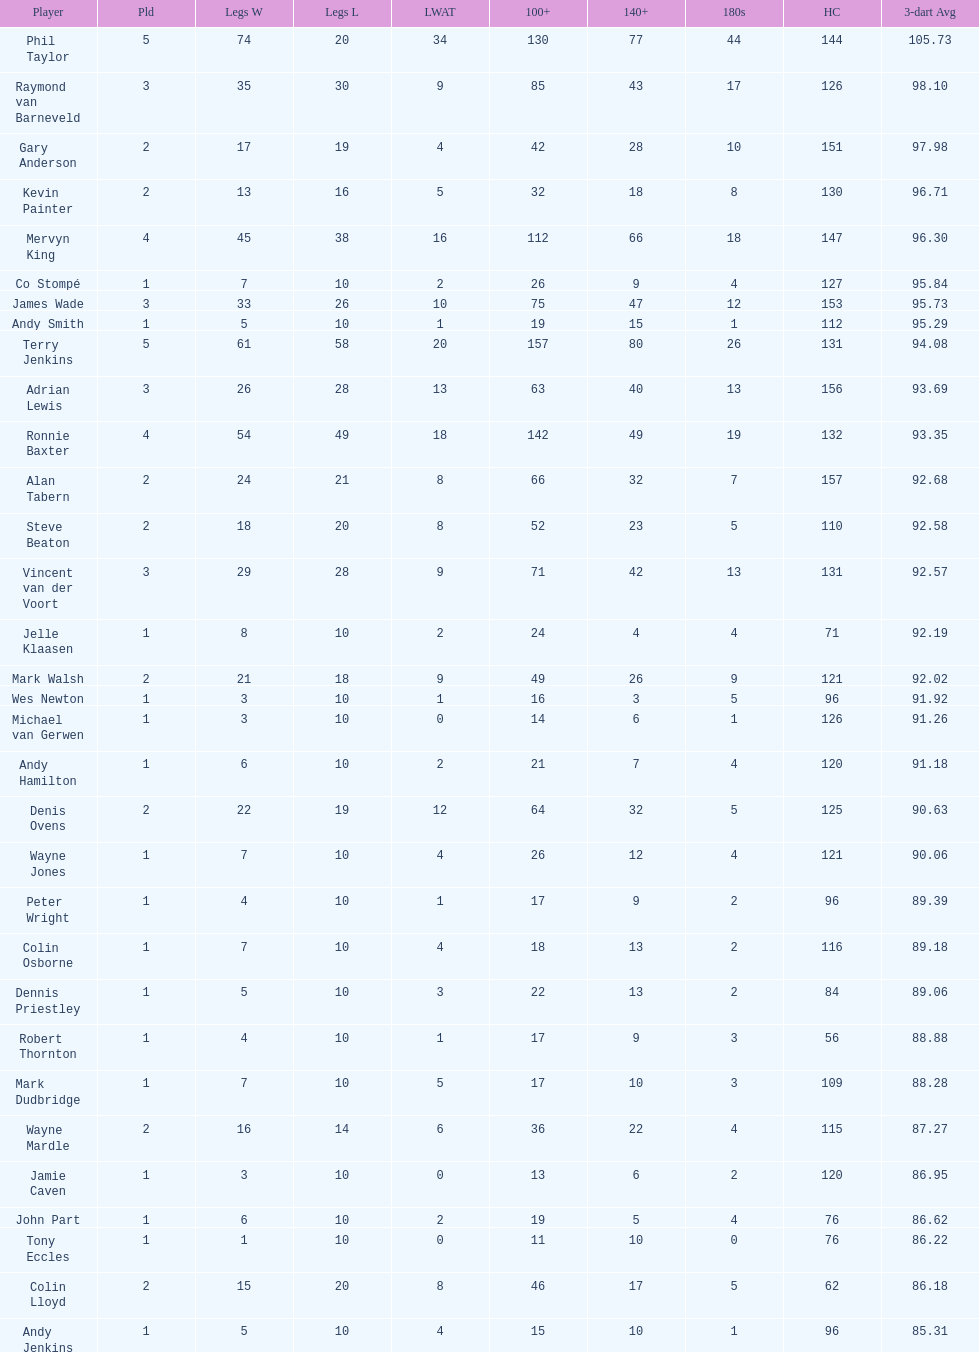What is the total amount of players who played more than 3 games? 4. 